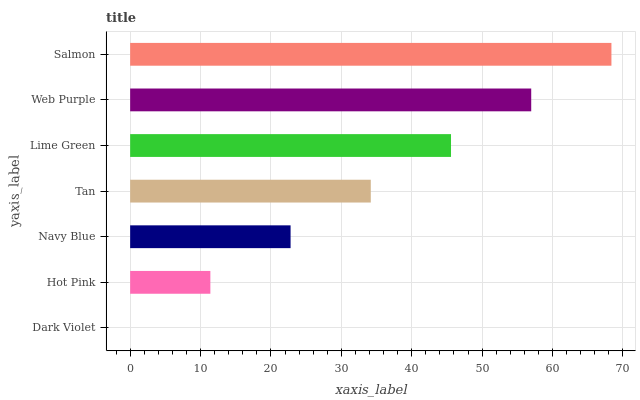Is Dark Violet the minimum?
Answer yes or no. Yes. Is Salmon the maximum?
Answer yes or no. Yes. Is Hot Pink the minimum?
Answer yes or no. No. Is Hot Pink the maximum?
Answer yes or no. No. Is Hot Pink greater than Dark Violet?
Answer yes or no. Yes. Is Dark Violet less than Hot Pink?
Answer yes or no. Yes. Is Dark Violet greater than Hot Pink?
Answer yes or no. No. Is Hot Pink less than Dark Violet?
Answer yes or no. No. Is Tan the high median?
Answer yes or no. Yes. Is Tan the low median?
Answer yes or no. Yes. Is Hot Pink the high median?
Answer yes or no. No. Is Hot Pink the low median?
Answer yes or no. No. 